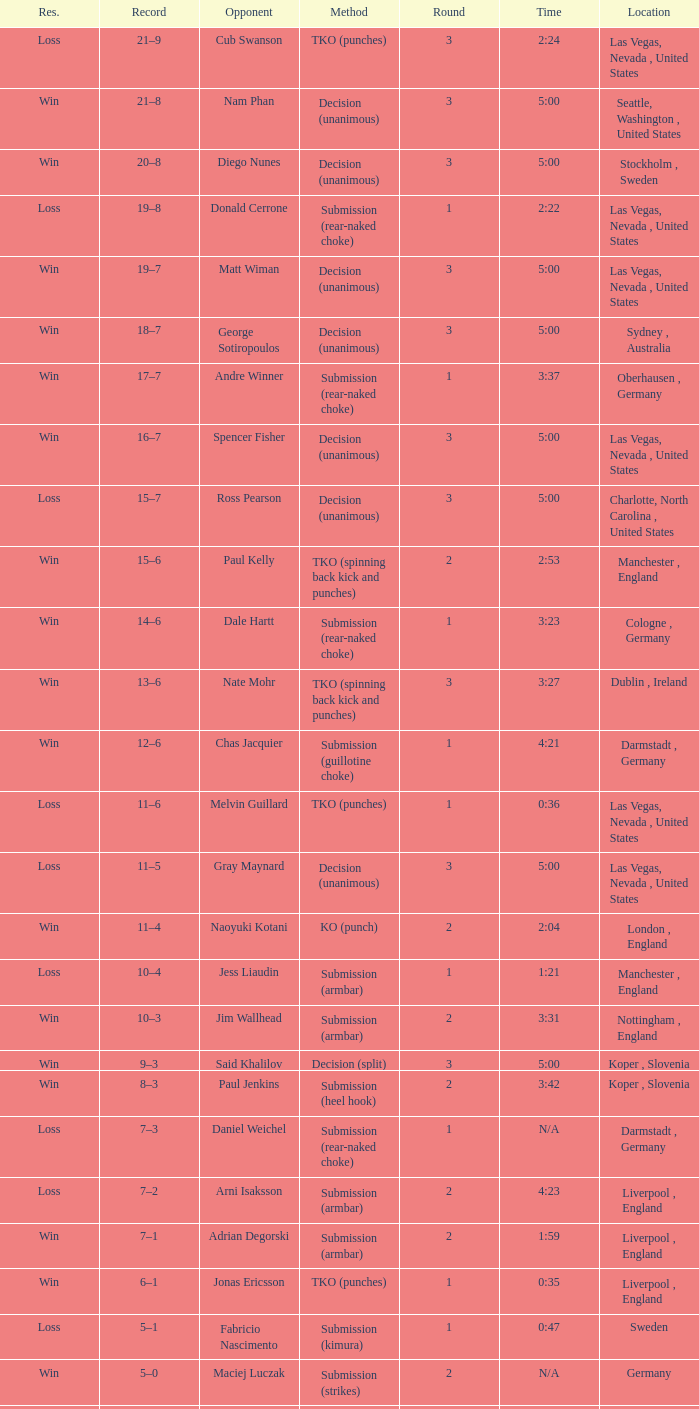What was the method of resolution for the fight against dale hartt? Submission (rear-naked choke). Can you give me this table as a dict? {'header': ['Res.', 'Record', 'Opponent', 'Method', 'Round', 'Time', 'Location'], 'rows': [['Loss', '21–9', 'Cub Swanson', 'TKO (punches)', '3', '2:24', 'Las Vegas, Nevada , United States'], ['Win', '21–8', 'Nam Phan', 'Decision (unanimous)', '3', '5:00', 'Seattle, Washington , United States'], ['Win', '20–8', 'Diego Nunes', 'Decision (unanimous)', '3', '5:00', 'Stockholm , Sweden'], ['Loss', '19–8', 'Donald Cerrone', 'Submission (rear-naked choke)', '1', '2:22', 'Las Vegas, Nevada , United States'], ['Win', '19–7', 'Matt Wiman', 'Decision (unanimous)', '3', '5:00', 'Las Vegas, Nevada , United States'], ['Win', '18–7', 'George Sotiropoulos', 'Decision (unanimous)', '3', '5:00', 'Sydney , Australia'], ['Win', '17–7', 'Andre Winner', 'Submission (rear-naked choke)', '1', '3:37', 'Oberhausen , Germany'], ['Win', '16–7', 'Spencer Fisher', 'Decision (unanimous)', '3', '5:00', 'Las Vegas, Nevada , United States'], ['Loss', '15–7', 'Ross Pearson', 'Decision (unanimous)', '3', '5:00', 'Charlotte, North Carolina , United States'], ['Win', '15–6', 'Paul Kelly', 'TKO (spinning back kick and punches)', '2', '2:53', 'Manchester , England'], ['Win', '14–6', 'Dale Hartt', 'Submission (rear-naked choke)', '1', '3:23', 'Cologne , Germany'], ['Win', '13–6', 'Nate Mohr', 'TKO (spinning back kick and punches)', '3', '3:27', 'Dublin , Ireland'], ['Win', '12–6', 'Chas Jacquier', 'Submission (guillotine choke)', '1', '4:21', 'Darmstadt , Germany'], ['Loss', '11–6', 'Melvin Guillard', 'TKO (punches)', '1', '0:36', 'Las Vegas, Nevada , United States'], ['Loss', '11–5', 'Gray Maynard', 'Decision (unanimous)', '3', '5:00', 'Las Vegas, Nevada , United States'], ['Win', '11–4', 'Naoyuki Kotani', 'KO (punch)', '2', '2:04', 'London , England'], ['Loss', '10–4', 'Jess Liaudin', 'Submission (armbar)', '1', '1:21', 'Manchester , England'], ['Win', '10–3', 'Jim Wallhead', 'Submission (armbar)', '2', '3:31', 'Nottingham , England'], ['Win', '9–3', 'Said Khalilov', 'Decision (split)', '3', '5:00', 'Koper , Slovenia'], ['Win', '8–3', 'Paul Jenkins', 'Submission (heel hook)', '2', '3:42', 'Koper , Slovenia'], ['Loss', '7–3', 'Daniel Weichel', 'Submission (rear-naked choke)', '1', 'N/A', 'Darmstadt , Germany'], ['Loss', '7–2', 'Arni Isaksson', 'Submission (armbar)', '2', '4:23', 'Liverpool , England'], ['Win', '7–1', 'Adrian Degorski', 'Submission (armbar)', '2', '1:59', 'Liverpool , England'], ['Win', '6–1', 'Jonas Ericsson', 'TKO (punches)', '1', '0:35', 'Liverpool , England'], ['Loss', '5–1', 'Fabricio Nascimento', 'Submission (kimura)', '1', '0:47', 'Sweden'], ['Win', '5–0', 'Maciej Luczak', 'Submission (strikes)', '2', 'N/A', 'Germany'], ['Win', '4–0', 'Dylan van Kooten', 'Submission (choke)', '1', 'N/A', 'Düsseldorf , Germany'], ['Win', '3–0', 'Kenneth Rosfort-Nees', 'TKO (cut)', '1', '5:00', 'Stockholm , Sweden'], ['Win', '2–0', 'Mohamed Omar', 'Decision (unanimous)', '3', '5:00', 'Trier , Germany'], ['Win', '1–0', 'Kordian Szukala', 'Submission (strikes)', '1', '0:17', 'Lübbecke , Germany']]} 